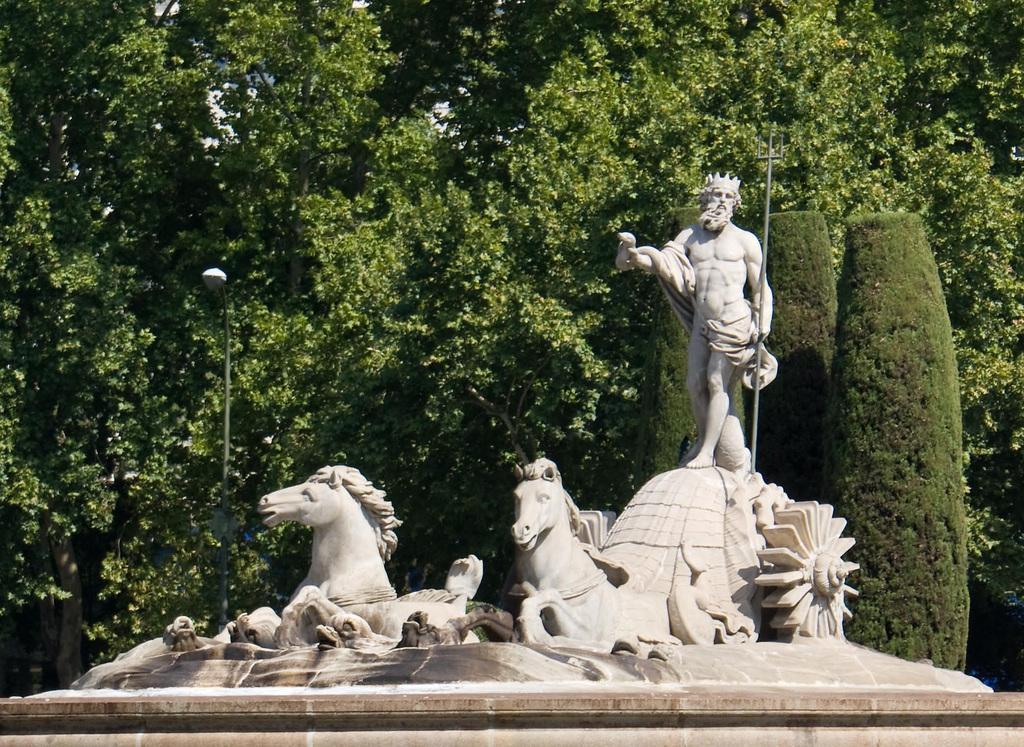Describe this image in one or two sentences. In this image we can see the sculpture. On the backside we can see a group of trees and a street pole. 